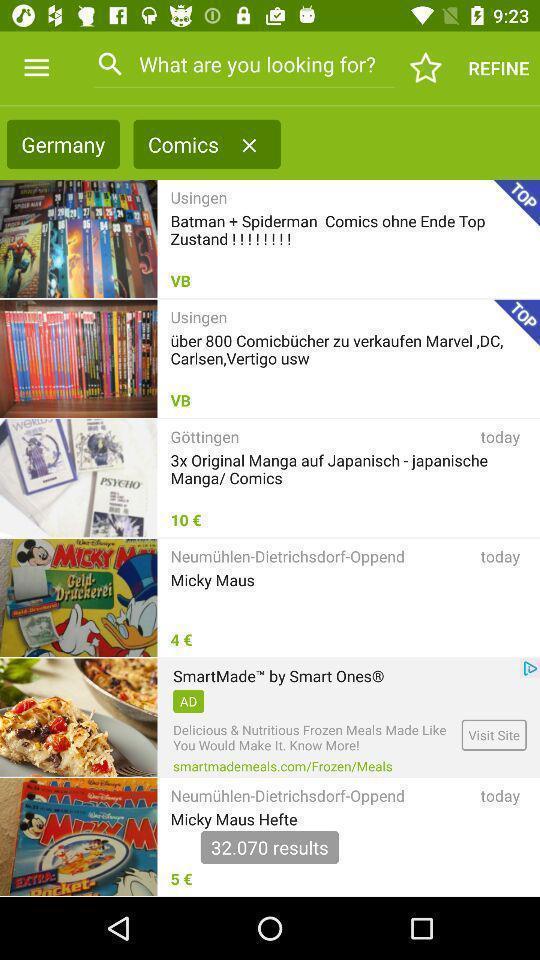Describe the content in this image. Screen showing comics with search bar. 